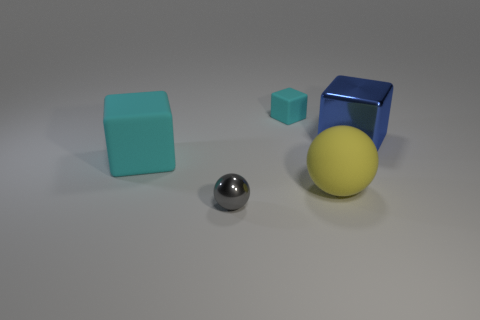Subtract all shiny cubes. How many cubes are left? 2 Add 4 blue metal blocks. How many objects exist? 9 Subtract all cubes. How many objects are left? 2 Subtract 3 cubes. How many cubes are left? 0 Add 5 yellow things. How many yellow things exist? 6 Subtract all blue cubes. How many cubes are left? 2 Subtract 0 blue spheres. How many objects are left? 5 Subtract all red cubes. Subtract all brown cylinders. How many cubes are left? 3 Subtract all gray cylinders. How many purple balls are left? 0 Subtract all brown rubber cylinders. Subtract all large rubber objects. How many objects are left? 3 